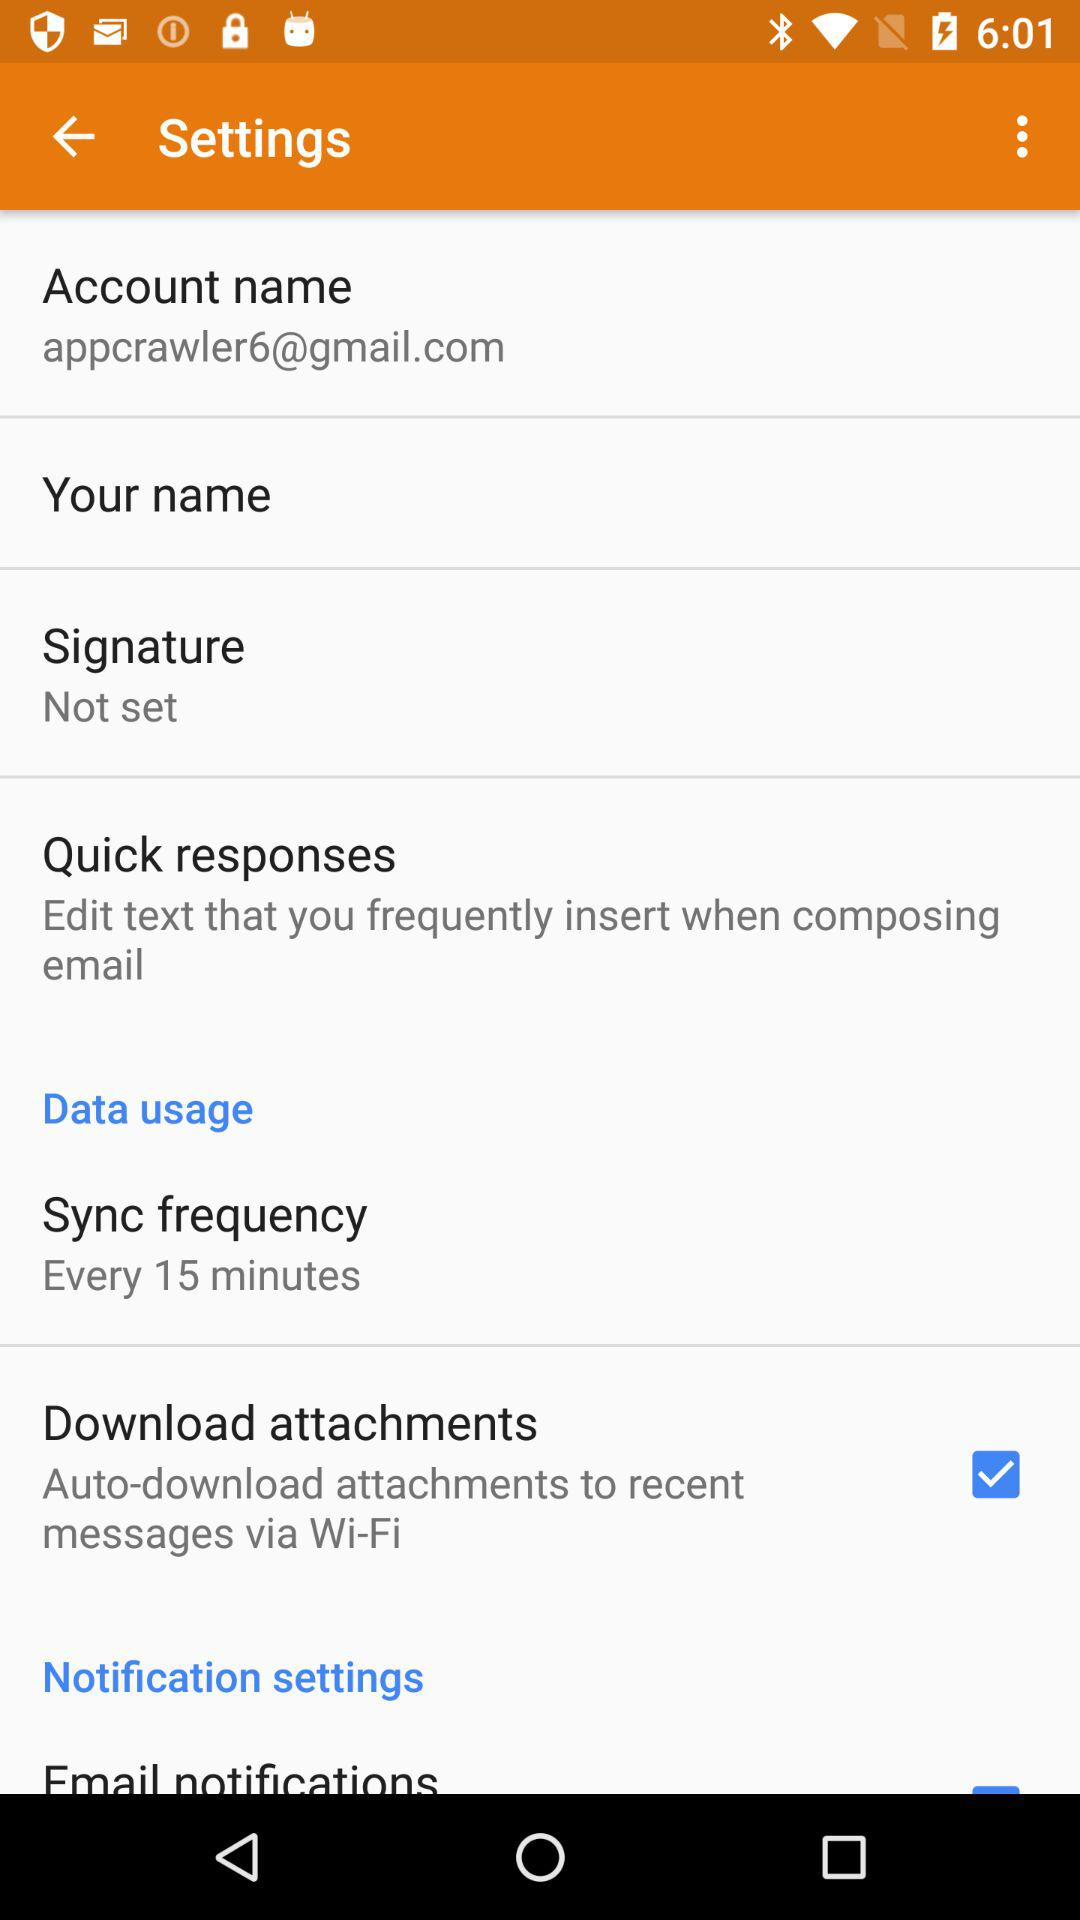What is the sync frequency time duration? The sync frequency is set for every 15 minutes. 